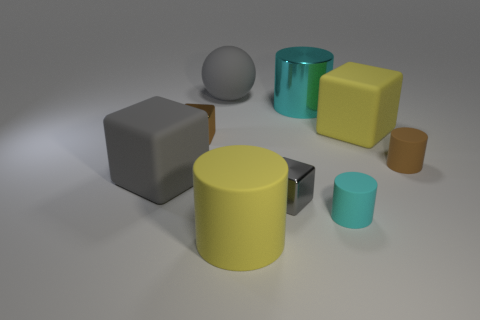Subtract all brown balls. How many cyan cylinders are left? 2 Add 1 blue metallic cylinders. How many objects exist? 10 Subtract all brown matte cylinders. How many cylinders are left? 3 Subtract all brown cylinders. How many cylinders are left? 3 Subtract all spheres. How many objects are left? 8 Subtract all blue cylinders. Subtract all red spheres. How many cylinders are left? 4 Subtract all small brown blocks. Subtract all big gray objects. How many objects are left? 6 Add 4 rubber things. How many rubber things are left? 10 Add 1 tiny brown objects. How many tiny brown objects exist? 3 Subtract 0 red cylinders. How many objects are left? 9 